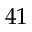<formula> <loc_0><loc_0><loc_500><loc_500>4 1</formula> 